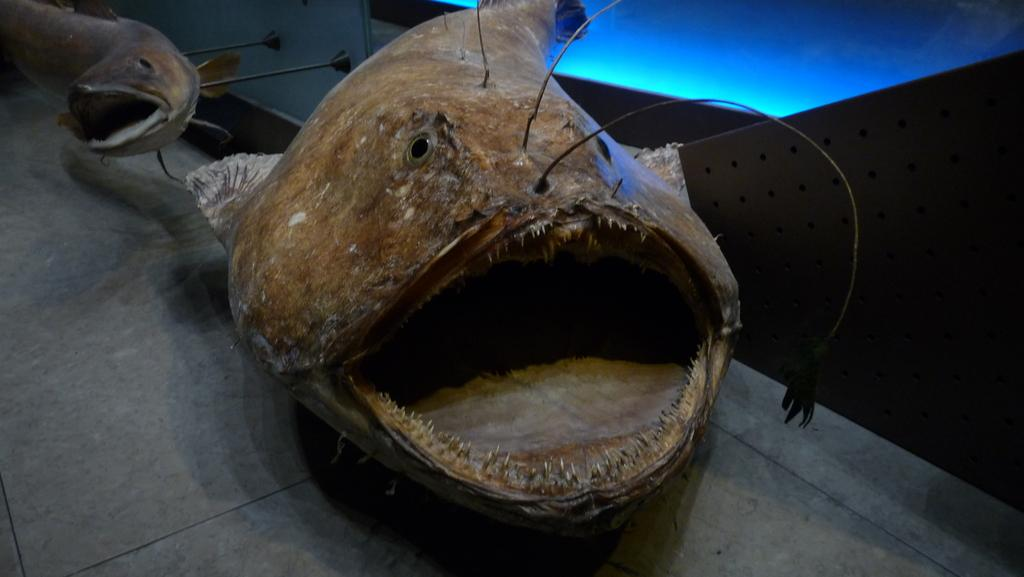What is the main subject of the image? There is a fish in the image. Can you describe the setting of the fish in the image? There is a fish mounted on a wall with small rods in the background of the image. What type of curtain is hanging in front of the fish in the image? There is no curtain present in the image; it features a mounted fish with small rods in the background. 